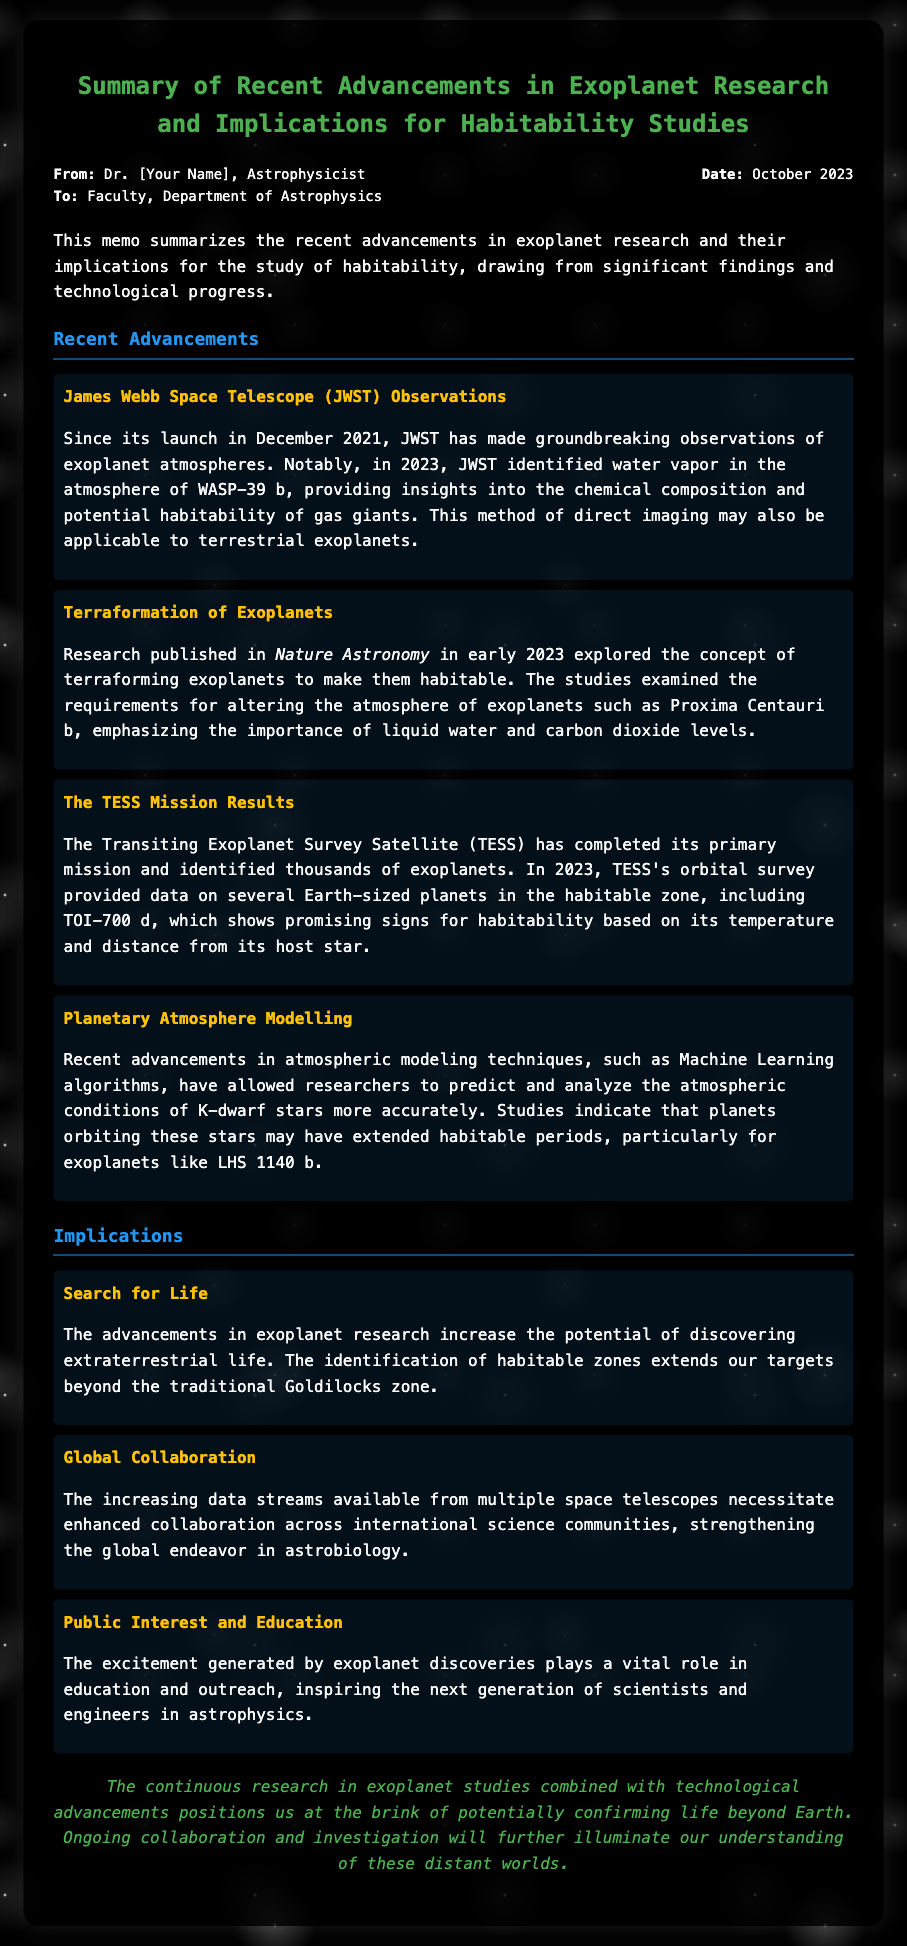What is the name of the telescope that made observations of exoplanet atmospheres? The memo mentions that the James Webb Space Telescope (JWST) made groundbreaking observations of exoplanet atmospheres.
Answer: James Webb Space Telescope (JWST) What exoplanet's atmosphere was identified to contain water vapor? The memo specifically states that in 2023, JWST identified water vapor in the atmosphere of WASP-39 b.
Answer: WASP-39 b Who published research on terraforming exoplanets? According to the document, research on terraforming was published in Nature Astronomy.
Answer: Nature Astronomy What is the name of the Earth-sized planet identified by the TESS mission? The memo indicates that TESS identified the Earth-sized planet TOI-700 d in the habitable zone.
Answer: TOI-700 d What is a potential implication of the advancements in exoplanet research? The document mentions that one implication is the increased potential of discovering extraterrestrial life.
Answer: Search for Life Which star types may have extended habitable periods for orbiting planets? The memo indicates that studies show planets orbiting K-dwarf stars may have extended habitable periods.
Answer: K-dwarf stars What is the date of this memo? The date section of the memo specifies that it was written in October 2023.
Answer: October 2023 What role does public interest play in exoplanet discoveries? The memo states that the excitement generated by exoplanet discoveries plays a vital role in education and outreach.
Answer: Education and outreach What is the primary focus of the document? The memo summarizes recent advancements in exoplanet research and their implications for habitability studies.
Answer: Recent advancements in exoplanet research 